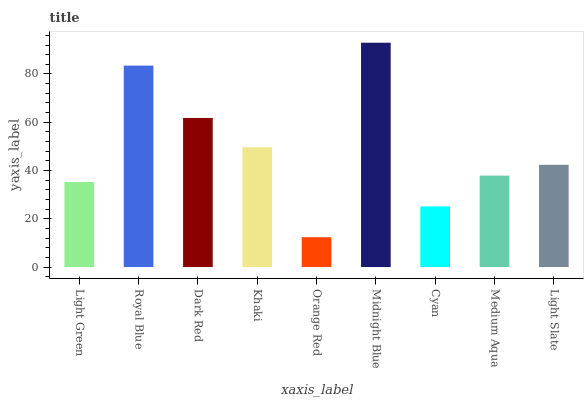Is Orange Red the minimum?
Answer yes or no. Yes. Is Midnight Blue the maximum?
Answer yes or no. Yes. Is Royal Blue the minimum?
Answer yes or no. No. Is Royal Blue the maximum?
Answer yes or no. No. Is Royal Blue greater than Light Green?
Answer yes or no. Yes. Is Light Green less than Royal Blue?
Answer yes or no. Yes. Is Light Green greater than Royal Blue?
Answer yes or no. No. Is Royal Blue less than Light Green?
Answer yes or no. No. Is Light Slate the high median?
Answer yes or no. Yes. Is Light Slate the low median?
Answer yes or no. Yes. Is Medium Aqua the high median?
Answer yes or no. No. Is Dark Red the low median?
Answer yes or no. No. 